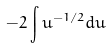<formula> <loc_0><loc_0><loc_500><loc_500>- 2 \int u ^ { - 1 / 2 } d u</formula> 